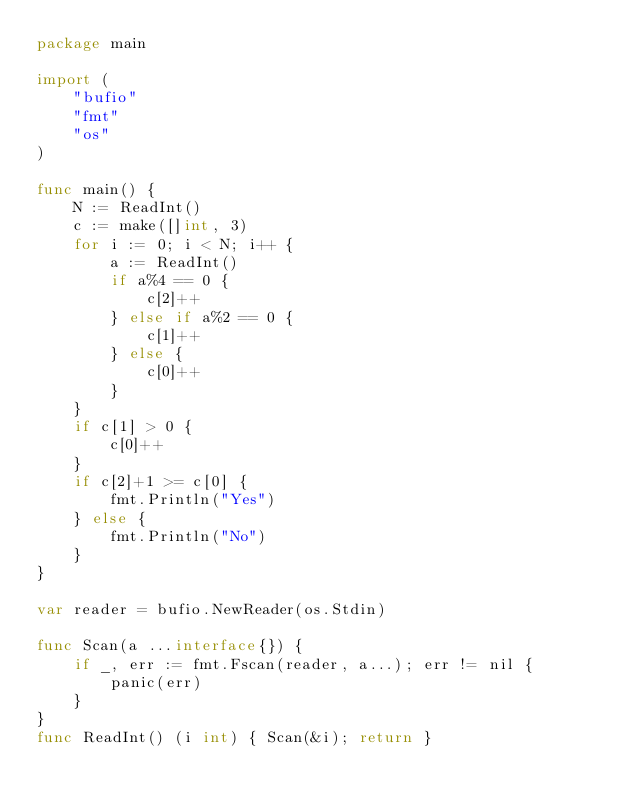<code> <loc_0><loc_0><loc_500><loc_500><_Go_>package main

import (
	"bufio"
	"fmt"
	"os"
)

func main() {
	N := ReadInt()
	c := make([]int, 3)
	for i := 0; i < N; i++ {
		a := ReadInt()
		if a%4 == 0 {
			c[2]++
		} else if a%2 == 0 {
			c[1]++
		} else {
			c[0]++
		}
	}
	if c[1] > 0 {
		c[0]++
	}
	if c[2]+1 >= c[0] {
		fmt.Println("Yes")
	} else {
		fmt.Println("No")
	}
}

var reader = bufio.NewReader(os.Stdin)

func Scan(a ...interface{}) {
	if _, err := fmt.Fscan(reader, a...); err != nil {
		panic(err)
	}
}
func ReadInt() (i int) { Scan(&i); return }
</code> 